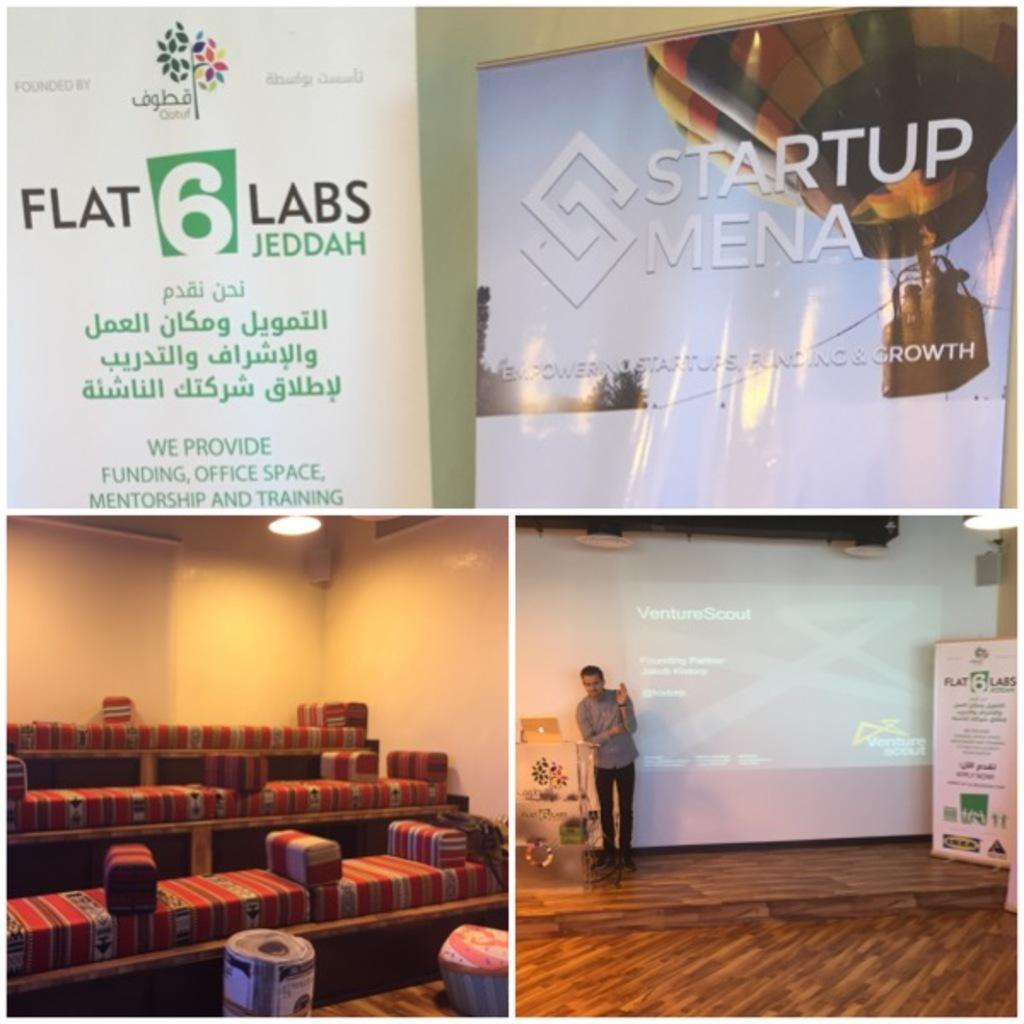What type of decorations are present in the image? There are banners in the image. What is the main object in the image? There is a screen in the image. What type of furniture is in the image? There are sofas in the image. What type of architectural feature is visible in the image? There is a wall in the image. Can you describe the presence of a person in the image? There is a person standing in the image. What type of farm animals can be seen on the sofas in the image? There are no farm animals present on the sofas in the image. What type of thrill-seeking activity is the person participating in the image? There is no indication of any thrill-seeking activity in the image. Can you tell me how many zippers are visible on the banners in the image? There is no mention of any zippers on the banners in the image. 